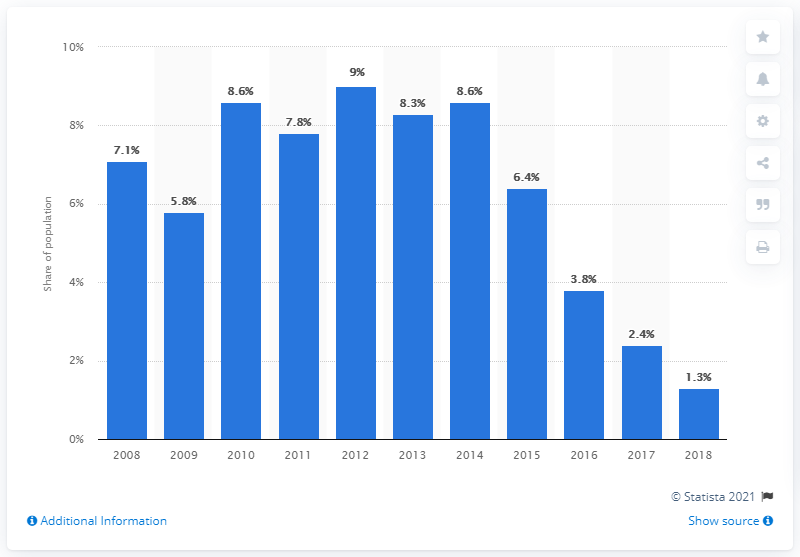Identify some key points in this picture. In 2018, the poverty headcount ratio at national poverty lines in Ukraine was 1.3, meaning that 1.3 out of every 100 individuals in Ukraine lived in poverty. 